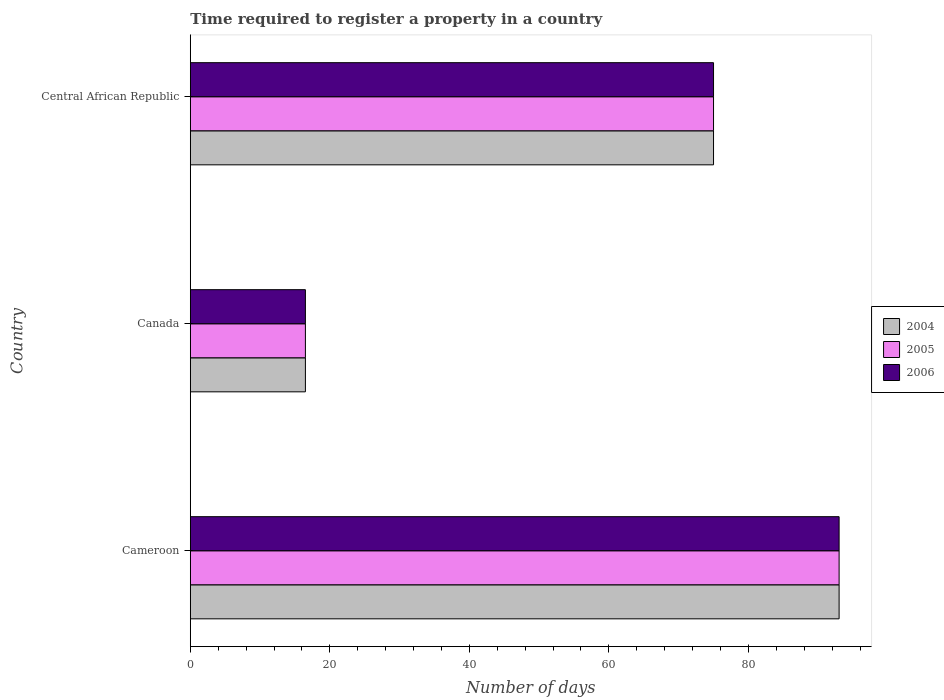How many different coloured bars are there?
Your answer should be very brief. 3. Are the number of bars per tick equal to the number of legend labels?
Provide a short and direct response. Yes. How many bars are there on the 1st tick from the top?
Provide a short and direct response. 3. How many bars are there on the 1st tick from the bottom?
Keep it short and to the point. 3. What is the label of the 2nd group of bars from the top?
Provide a short and direct response. Canada. In how many cases, is the number of bars for a given country not equal to the number of legend labels?
Provide a short and direct response. 0. What is the number of days required to register a property in 2006 in Central African Republic?
Give a very brief answer. 75. Across all countries, what is the maximum number of days required to register a property in 2004?
Give a very brief answer. 93. In which country was the number of days required to register a property in 2006 maximum?
Your response must be concise. Cameroon. What is the total number of days required to register a property in 2006 in the graph?
Give a very brief answer. 184.5. What is the difference between the number of days required to register a property in 2004 in Canada and that in Central African Republic?
Your answer should be compact. -58.5. What is the difference between the number of days required to register a property in 2004 in Cameroon and the number of days required to register a property in 2006 in Canada?
Give a very brief answer. 76.5. What is the average number of days required to register a property in 2005 per country?
Keep it short and to the point. 61.5. What is the difference between the number of days required to register a property in 2006 and number of days required to register a property in 2004 in Cameroon?
Make the answer very short. 0. What is the ratio of the number of days required to register a property in 2004 in Cameroon to that in Central African Republic?
Your response must be concise. 1.24. Is the number of days required to register a property in 2005 in Cameroon less than that in Canada?
Provide a short and direct response. No. What is the difference between the highest and the lowest number of days required to register a property in 2006?
Offer a terse response. 76.5. What does the 2nd bar from the top in Central African Republic represents?
Ensure brevity in your answer.  2005. How many bars are there?
Offer a very short reply. 9. How many countries are there in the graph?
Provide a short and direct response. 3. Are the values on the major ticks of X-axis written in scientific E-notation?
Your answer should be very brief. No. Does the graph contain any zero values?
Offer a terse response. No. Where does the legend appear in the graph?
Offer a terse response. Center right. How many legend labels are there?
Your response must be concise. 3. What is the title of the graph?
Offer a very short reply. Time required to register a property in a country. What is the label or title of the X-axis?
Your answer should be compact. Number of days. What is the Number of days in 2004 in Cameroon?
Offer a terse response. 93. What is the Number of days of 2005 in Cameroon?
Your answer should be very brief. 93. What is the Number of days in 2006 in Cameroon?
Make the answer very short. 93. What is the Number of days in 2005 in Canada?
Keep it short and to the point. 16.5. What is the Number of days of 2006 in Canada?
Offer a very short reply. 16.5. What is the Number of days in 2006 in Central African Republic?
Offer a terse response. 75. Across all countries, what is the maximum Number of days of 2004?
Your answer should be compact. 93. Across all countries, what is the maximum Number of days in 2005?
Keep it short and to the point. 93. Across all countries, what is the maximum Number of days in 2006?
Your answer should be compact. 93. What is the total Number of days in 2004 in the graph?
Your response must be concise. 184.5. What is the total Number of days in 2005 in the graph?
Your answer should be very brief. 184.5. What is the total Number of days of 2006 in the graph?
Provide a succinct answer. 184.5. What is the difference between the Number of days of 2004 in Cameroon and that in Canada?
Ensure brevity in your answer.  76.5. What is the difference between the Number of days in 2005 in Cameroon and that in Canada?
Ensure brevity in your answer.  76.5. What is the difference between the Number of days in 2006 in Cameroon and that in Canada?
Your answer should be compact. 76.5. What is the difference between the Number of days of 2004 in Cameroon and that in Central African Republic?
Make the answer very short. 18. What is the difference between the Number of days in 2005 in Cameroon and that in Central African Republic?
Offer a very short reply. 18. What is the difference between the Number of days of 2006 in Cameroon and that in Central African Republic?
Make the answer very short. 18. What is the difference between the Number of days of 2004 in Canada and that in Central African Republic?
Keep it short and to the point. -58.5. What is the difference between the Number of days of 2005 in Canada and that in Central African Republic?
Provide a short and direct response. -58.5. What is the difference between the Number of days of 2006 in Canada and that in Central African Republic?
Ensure brevity in your answer.  -58.5. What is the difference between the Number of days of 2004 in Cameroon and the Number of days of 2005 in Canada?
Offer a terse response. 76.5. What is the difference between the Number of days of 2004 in Cameroon and the Number of days of 2006 in Canada?
Your answer should be very brief. 76.5. What is the difference between the Number of days of 2005 in Cameroon and the Number of days of 2006 in Canada?
Provide a short and direct response. 76.5. What is the difference between the Number of days of 2004 in Cameroon and the Number of days of 2005 in Central African Republic?
Offer a terse response. 18. What is the difference between the Number of days of 2004 in Cameroon and the Number of days of 2006 in Central African Republic?
Make the answer very short. 18. What is the difference between the Number of days of 2005 in Cameroon and the Number of days of 2006 in Central African Republic?
Offer a very short reply. 18. What is the difference between the Number of days in 2004 in Canada and the Number of days in 2005 in Central African Republic?
Offer a very short reply. -58.5. What is the difference between the Number of days in 2004 in Canada and the Number of days in 2006 in Central African Republic?
Give a very brief answer. -58.5. What is the difference between the Number of days in 2005 in Canada and the Number of days in 2006 in Central African Republic?
Your answer should be compact. -58.5. What is the average Number of days in 2004 per country?
Your response must be concise. 61.5. What is the average Number of days of 2005 per country?
Keep it short and to the point. 61.5. What is the average Number of days in 2006 per country?
Your response must be concise. 61.5. What is the difference between the Number of days of 2004 and Number of days of 2005 in Cameroon?
Provide a short and direct response. 0. What is the difference between the Number of days of 2004 and Number of days of 2005 in Canada?
Your response must be concise. 0. What is the difference between the Number of days in 2004 and Number of days in 2006 in Canada?
Your answer should be compact. 0. What is the difference between the Number of days in 2005 and Number of days in 2006 in Canada?
Provide a short and direct response. 0. What is the difference between the Number of days in 2004 and Number of days in 2005 in Central African Republic?
Keep it short and to the point. 0. What is the difference between the Number of days of 2005 and Number of days of 2006 in Central African Republic?
Keep it short and to the point. 0. What is the ratio of the Number of days of 2004 in Cameroon to that in Canada?
Provide a short and direct response. 5.64. What is the ratio of the Number of days of 2005 in Cameroon to that in Canada?
Give a very brief answer. 5.64. What is the ratio of the Number of days of 2006 in Cameroon to that in Canada?
Give a very brief answer. 5.64. What is the ratio of the Number of days of 2004 in Cameroon to that in Central African Republic?
Your response must be concise. 1.24. What is the ratio of the Number of days in 2005 in Cameroon to that in Central African Republic?
Provide a succinct answer. 1.24. What is the ratio of the Number of days of 2006 in Cameroon to that in Central African Republic?
Provide a succinct answer. 1.24. What is the ratio of the Number of days of 2004 in Canada to that in Central African Republic?
Ensure brevity in your answer.  0.22. What is the ratio of the Number of days of 2005 in Canada to that in Central African Republic?
Your response must be concise. 0.22. What is the ratio of the Number of days of 2006 in Canada to that in Central African Republic?
Your response must be concise. 0.22. What is the difference between the highest and the second highest Number of days of 2004?
Offer a terse response. 18. What is the difference between the highest and the lowest Number of days of 2004?
Give a very brief answer. 76.5. What is the difference between the highest and the lowest Number of days in 2005?
Provide a short and direct response. 76.5. What is the difference between the highest and the lowest Number of days of 2006?
Your response must be concise. 76.5. 